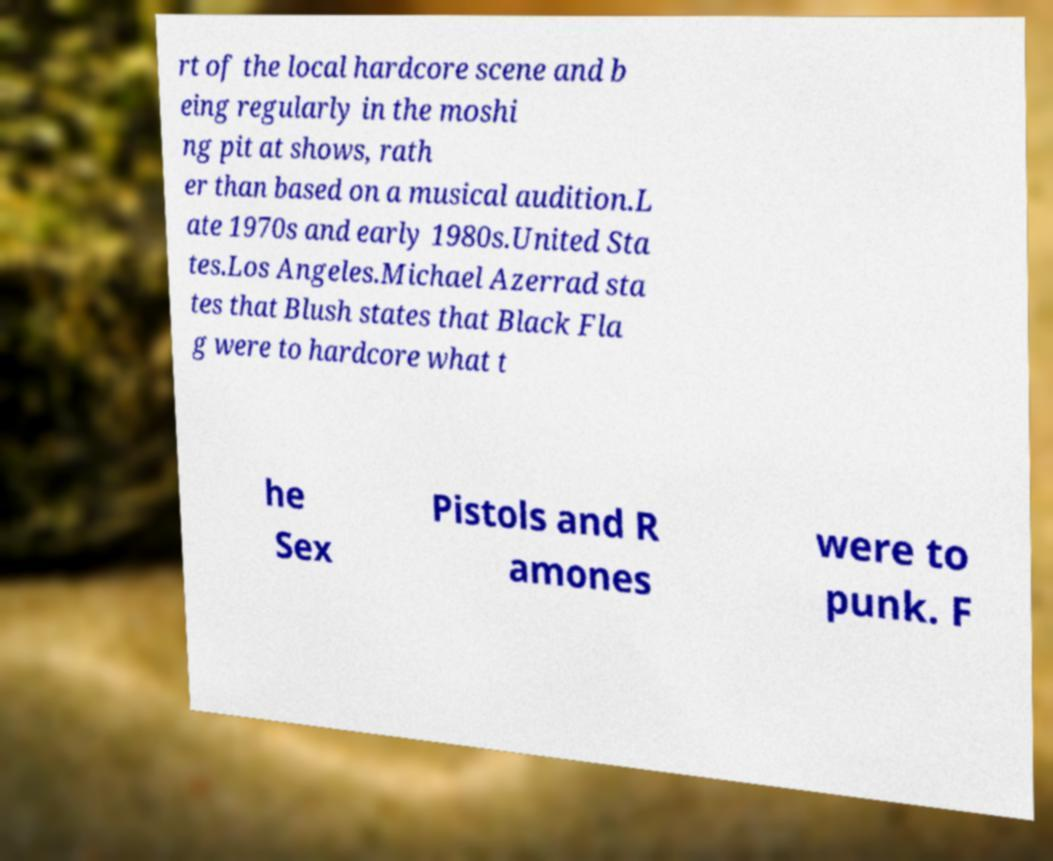Can you accurately transcribe the text from the provided image for me? rt of the local hardcore scene and b eing regularly in the moshi ng pit at shows, rath er than based on a musical audition.L ate 1970s and early 1980s.United Sta tes.Los Angeles.Michael Azerrad sta tes that Blush states that Black Fla g were to hardcore what t he Sex Pistols and R amones were to punk. F 